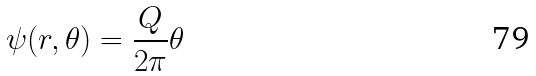<formula> <loc_0><loc_0><loc_500><loc_500>\psi ( r , \theta ) = \frac { Q } { 2 \pi } \theta</formula> 